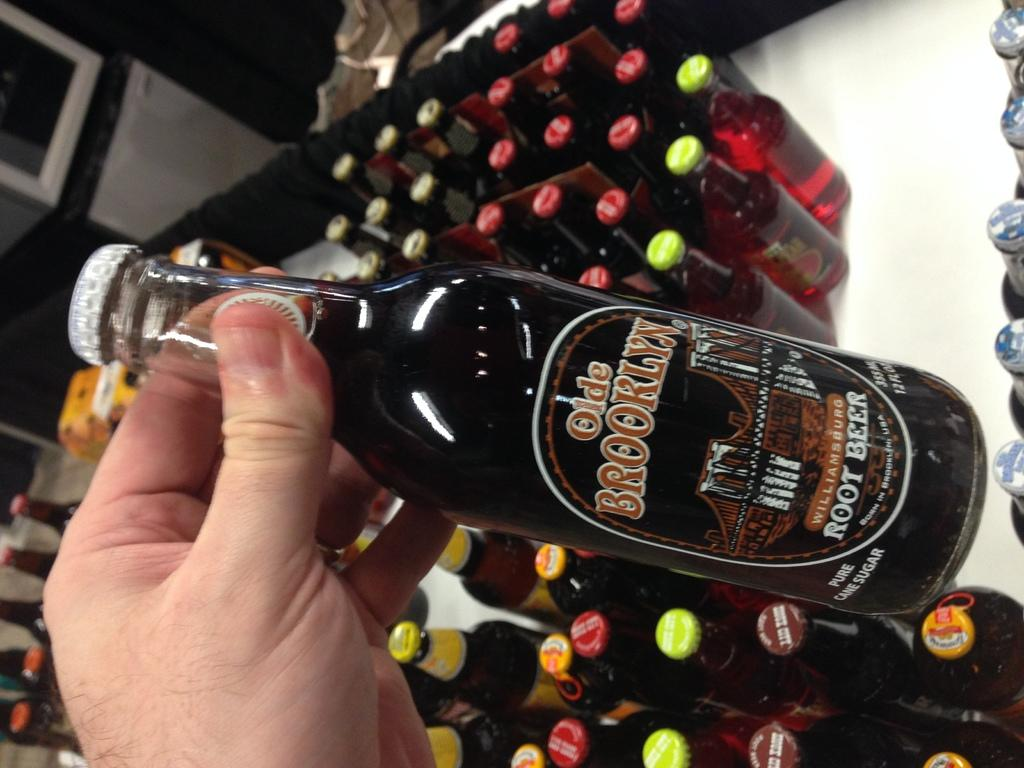<image>
Write a terse but informative summary of the picture. a hand holding a bottle of olde brooklyn root beer over a lot of other bottles 